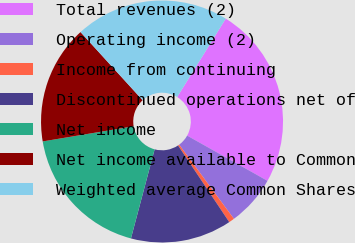Convert chart. <chart><loc_0><loc_0><loc_500><loc_500><pie_chart><fcel>Total revenues (2)<fcel>Operating income (2)<fcel>Income from continuing<fcel>Discontinued operations net of<fcel>Net income<fcel>Net income available to Common<fcel>Weighted average Common Shares<nl><fcel>24.33%<fcel>6.72%<fcel>0.75%<fcel>13.51%<fcel>18.23%<fcel>15.87%<fcel>20.59%<nl></chart> 